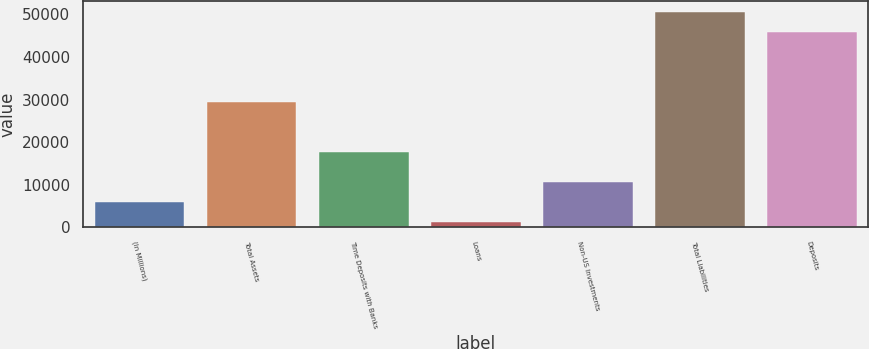<chart> <loc_0><loc_0><loc_500><loc_500><bar_chart><fcel>(In Millions)<fcel>Total Assets<fcel>Time Deposits with Banks<fcel>Loans<fcel>Non-US Investments<fcel>Total Liabilities<fcel>Deposits<nl><fcel>5862.04<fcel>29315.6<fcel>17785.5<fcel>1164<fcel>10560.1<fcel>50563.7<fcel>45865.7<nl></chart> 